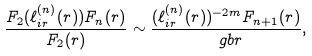Convert formula to latex. <formula><loc_0><loc_0><loc_500><loc_500>\frac { F _ { 2 } ( \ell _ { i r } ^ { ( n ) } ( r ) ) F _ { n } ( r ) } { F _ { 2 } ( r ) } \sim \frac { ( \ell _ { i r } ^ { ( n ) } ( r ) ) ^ { - 2 m } F _ { n + 1 } ( r ) } { \ g b r } ,</formula> 